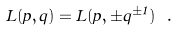Convert formula to latex. <formula><loc_0><loc_0><loc_500><loc_500>L ( p , q ) = L ( p , \pm q ^ { \pm 1 } ) \ .</formula> 